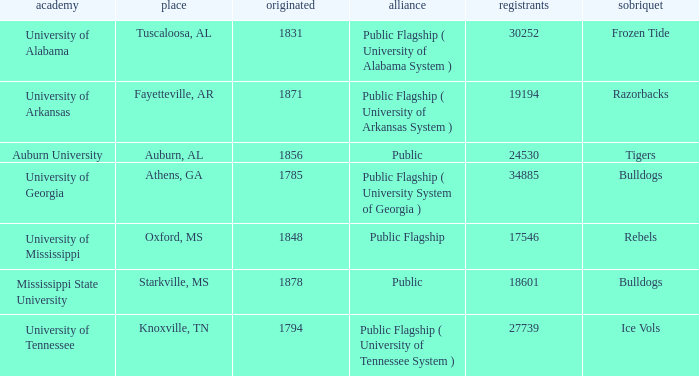What is the nickname of the University of Alabama? Frozen Tide. 